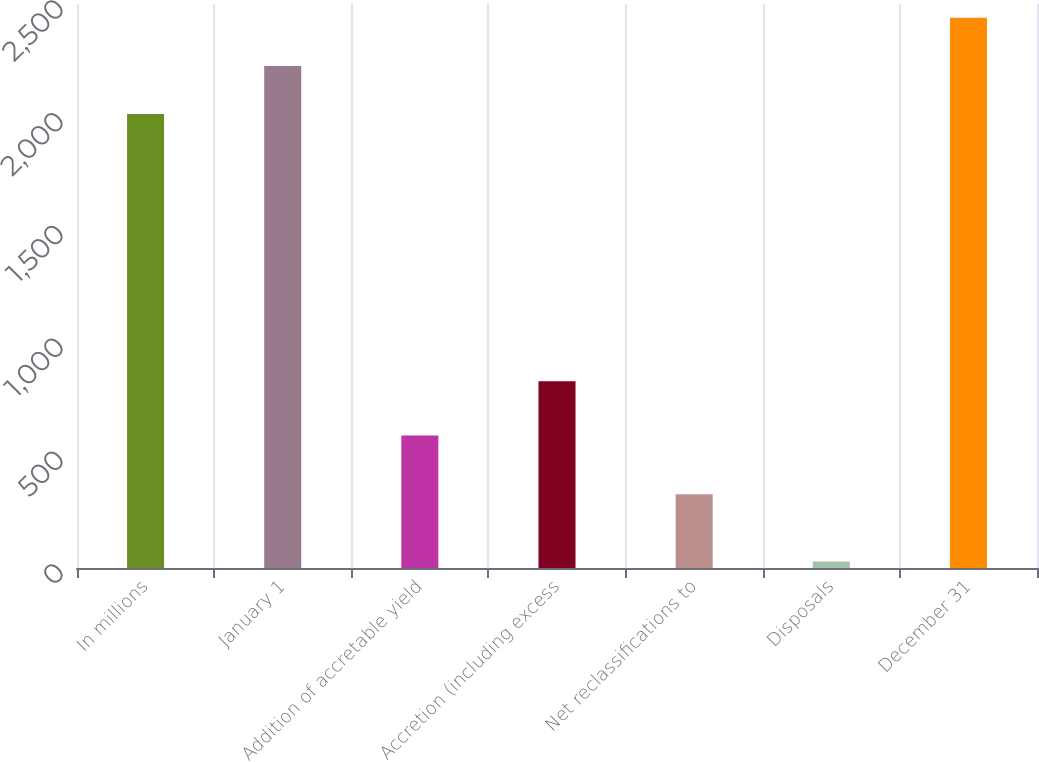Convert chart. <chart><loc_0><loc_0><loc_500><loc_500><bar_chart><fcel>In millions<fcel>January 1<fcel>Addition of accretable yield<fcel>Accretion (including excess<fcel>Net reclassifications to<fcel>Disposals<fcel>December 31<nl><fcel>2012<fcel>2225.7<fcel>587<fcel>828<fcel>327<fcel>29<fcel>2439.4<nl></chart> 